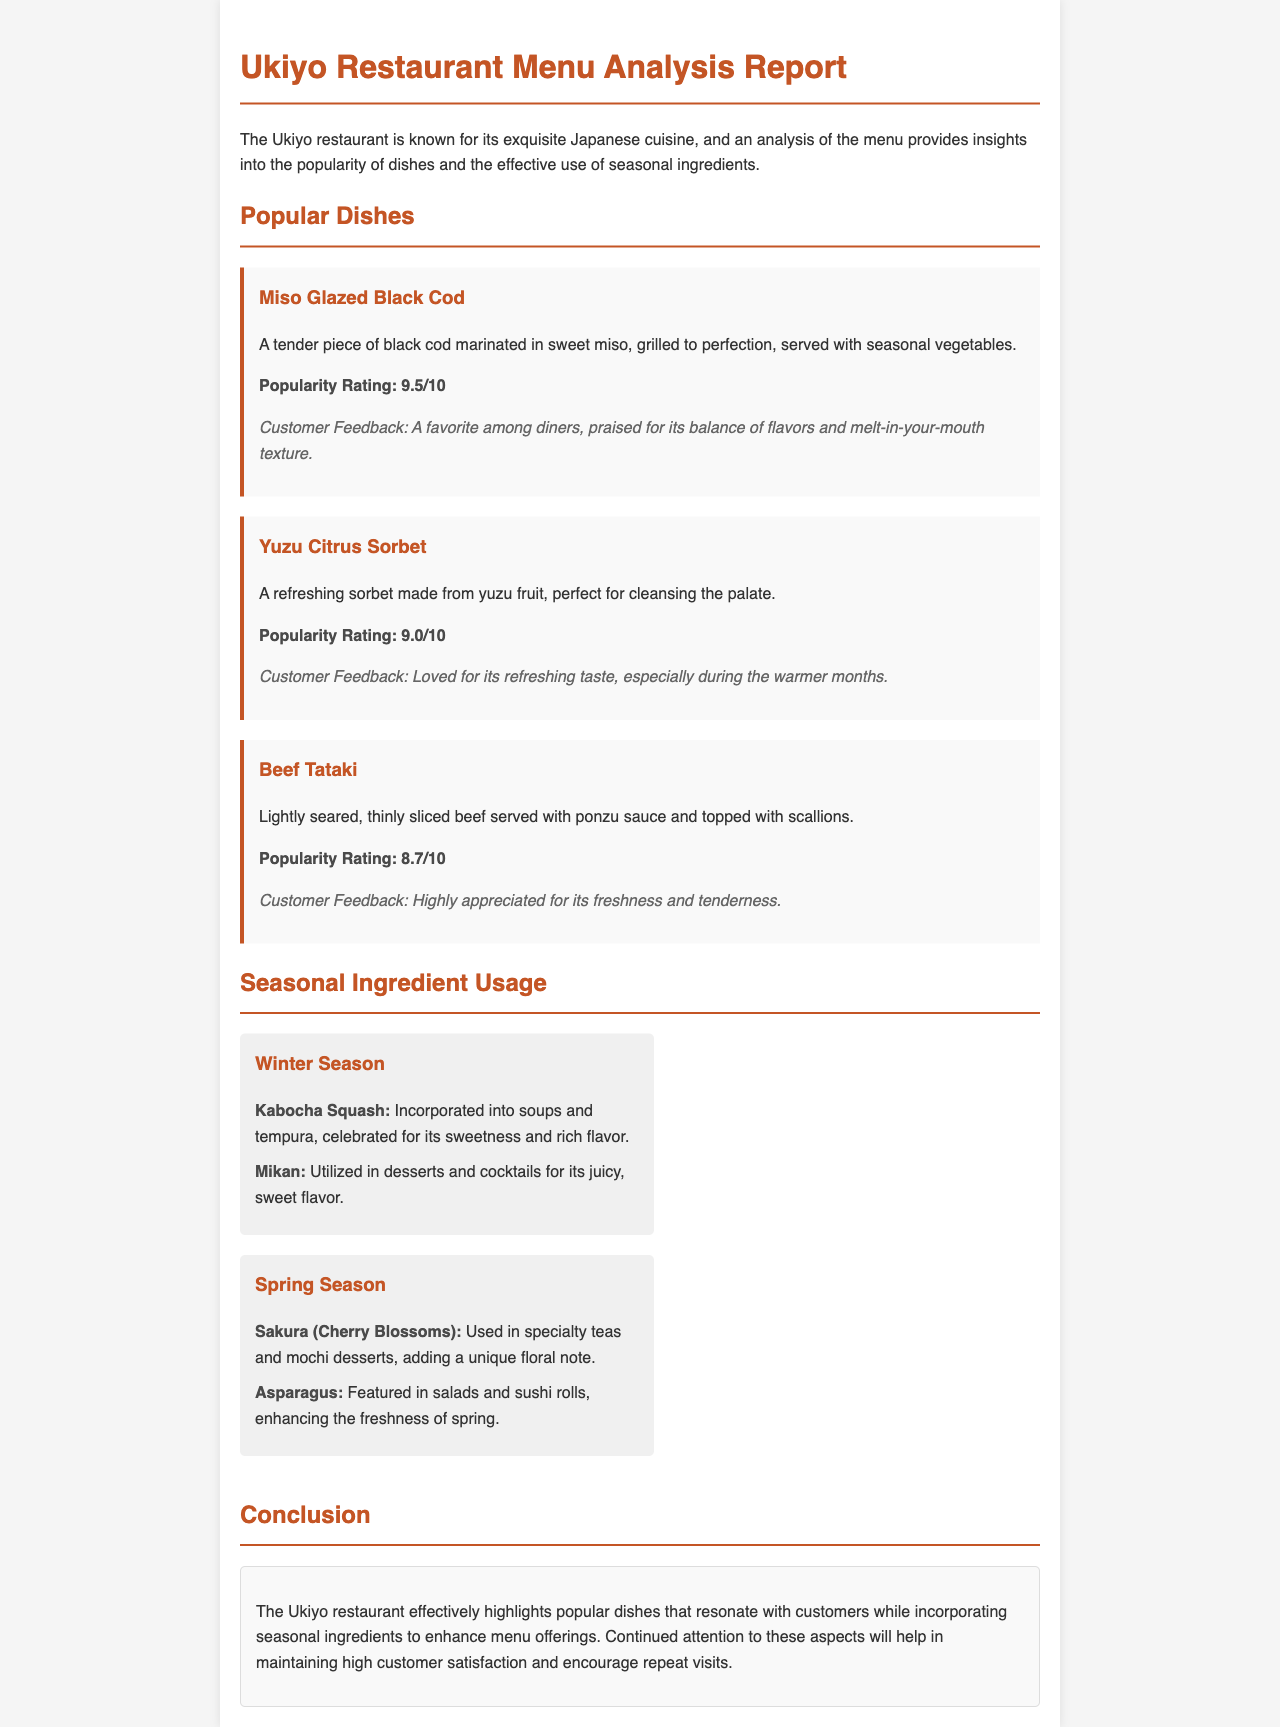What is the popularity rating of Miso Glazed Black Cod? The popularity rating is specifically mentioned in the document.
Answer: 9.5/10 What seasonal vegetable is used with the Miso Glazed Black Cod? The dish description includes a reference to serving it with seasonal vegetables.
Answer: Seasonal vegetables Which dish is described as a refreshing sorbet made from yuzu fruit? The dish is explicitly identified in its description within the report.
Answer: Yuzu Citrus Sorbet What ingredient is highlighted for use in winter soups and tempura? The document discusses Kabocha Squash under the winter seasonal ingredients.
Answer: Kabocha Squash What is the primary benefit of incorporating seasonal ingredients mentioned in the conclusion? The conclusion summarizes the restaurant's focus on maintaining customer satisfaction through seasonal ingredients.
Answer: High customer satisfaction Which season features Sakura (Cherry Blossoms) in the menu? The seasonal ingredient section specifies the usage of Sakura in spring.
Answer: Spring What feedback do customers give about Beef Tataki? Customer feedback regarding the dish is provided in the description section.
Answer: Highly appreciated for its freshness and tenderness What is the main focus of the Ukiyo restaurant according to the conclusion? The conclusion emphasizes the restaurant's commitment to maintaining high customer satisfaction and encouraging repeat visits.
Answer: Popular dishes and seasonal ingredients 